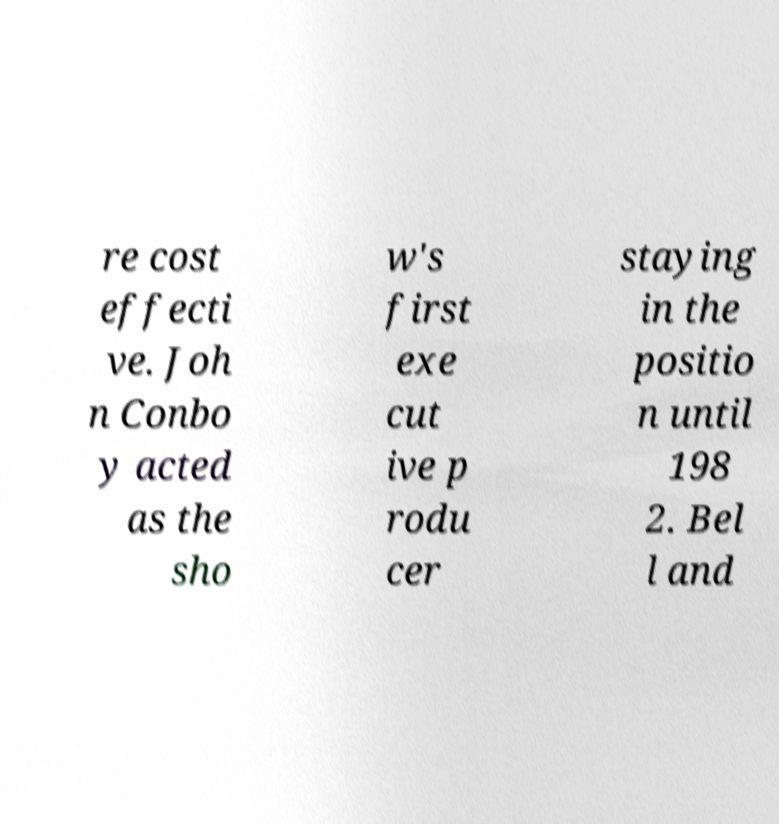Can you accurately transcribe the text from the provided image for me? re cost effecti ve. Joh n Conbo y acted as the sho w's first exe cut ive p rodu cer staying in the positio n until 198 2. Bel l and 